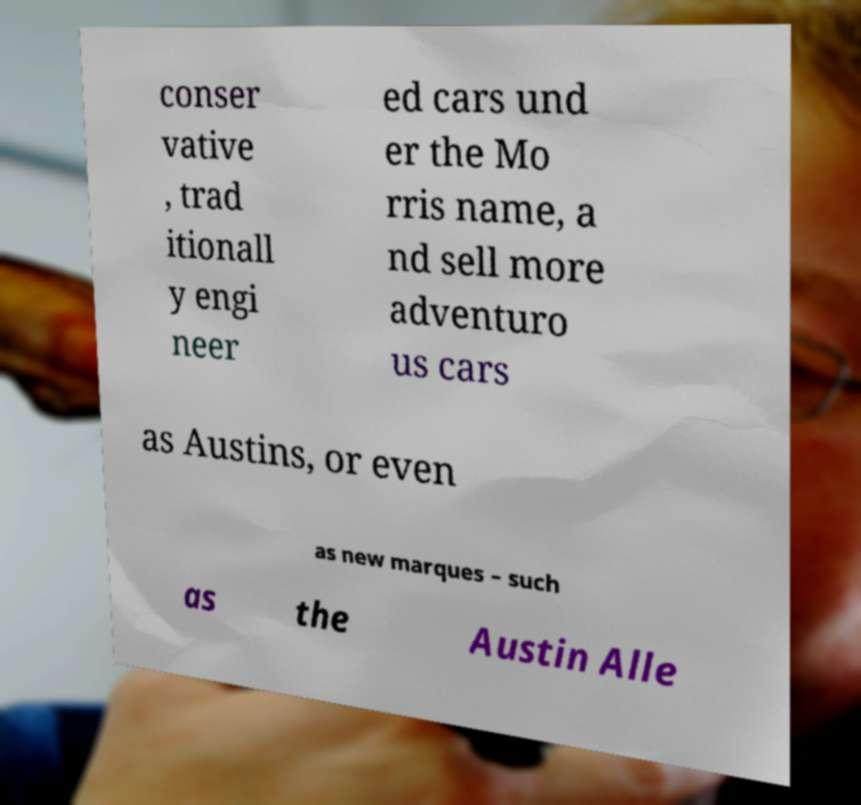Could you extract and type out the text from this image? conser vative , trad itionall y engi neer ed cars und er the Mo rris name, a nd sell more adventuro us cars as Austins, or even as new marques – such as the Austin Alle 